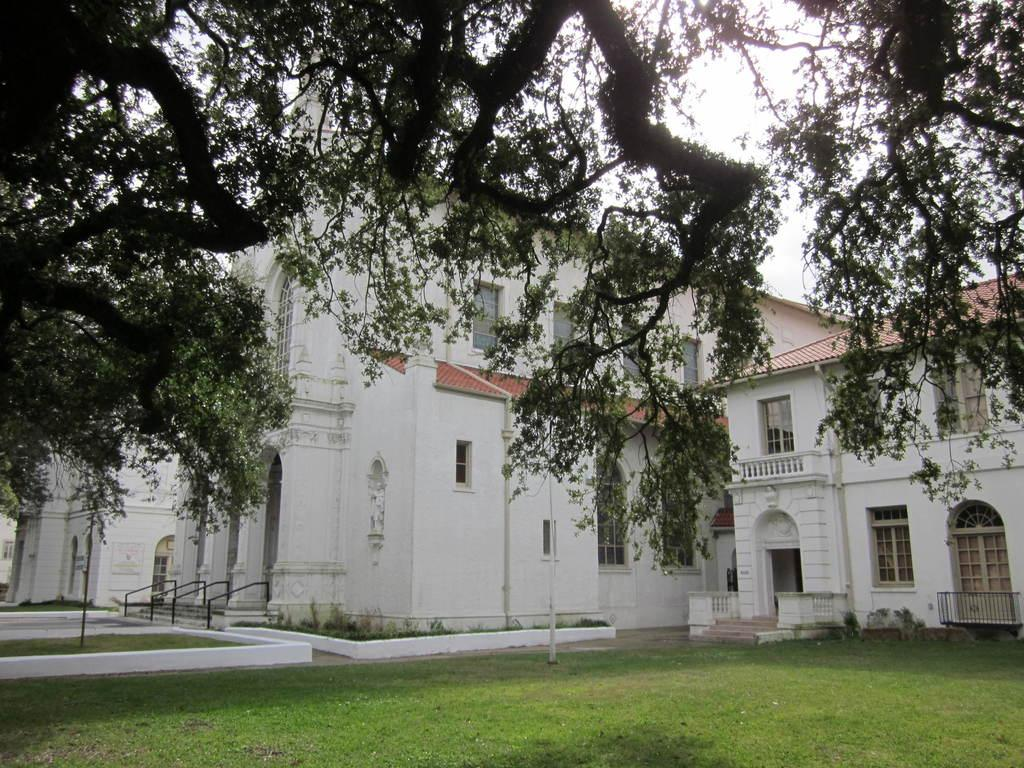What is the main subject in the center of the image? There is a house in the center of the image. What type of vegetation is visible at the bottom of the image? There is grass at the bottom of the image. What can be seen at the top of the image? There is a tree branch at the top of the image. How many blades of grass are visible in the image? It is not possible to count individual blades of grass in the image, as they are depicted as a collective mass of grass. 